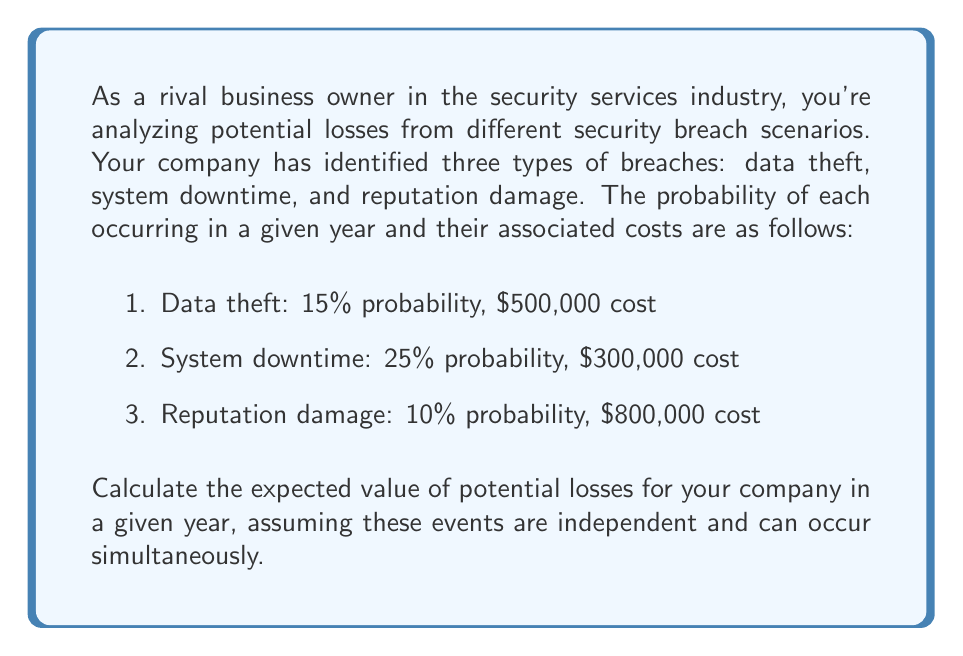Solve this math problem. To solve this problem, we need to use the concept of expected value in probability theory. The expected value is calculated by multiplying each possible outcome by its probability of occurrence and then summing these products.

Let's break down the solution step-by-step:

1. First, we need to calculate the expected value for each type of breach:

   a. Data theft: 
      $E(\text{data theft}) = 0.15 \times \$500,000 = \$75,000$

   b. System downtime:
      $E(\text{system downtime}) = 0.25 \times \$300,000 = \$75,000$

   c. Reputation damage:
      $E(\text{reputation damage}) = 0.10 \times \$800,000 = \$80,000$

2. Since these events are independent and can occur simultaneously, we need to sum up the expected values of all scenarios:

   $E(\text{total losses}) = E(\text{data theft}) + E(\text{system downtime}) + E(\text{reputation damage})$

3. Substituting the values:

   $E(\text{total losses}) = \$75,000 + \$75,000 + \$80,000 = \$230,000$

Therefore, the expected value of potential losses for your company in a given year is $230,000.

It's important to note that this calculation assumes independence between the events. In reality, these events might be correlated, which would require a more complex probability model.
Answer: The expected value of potential losses for the company in a given year is $230,000. 